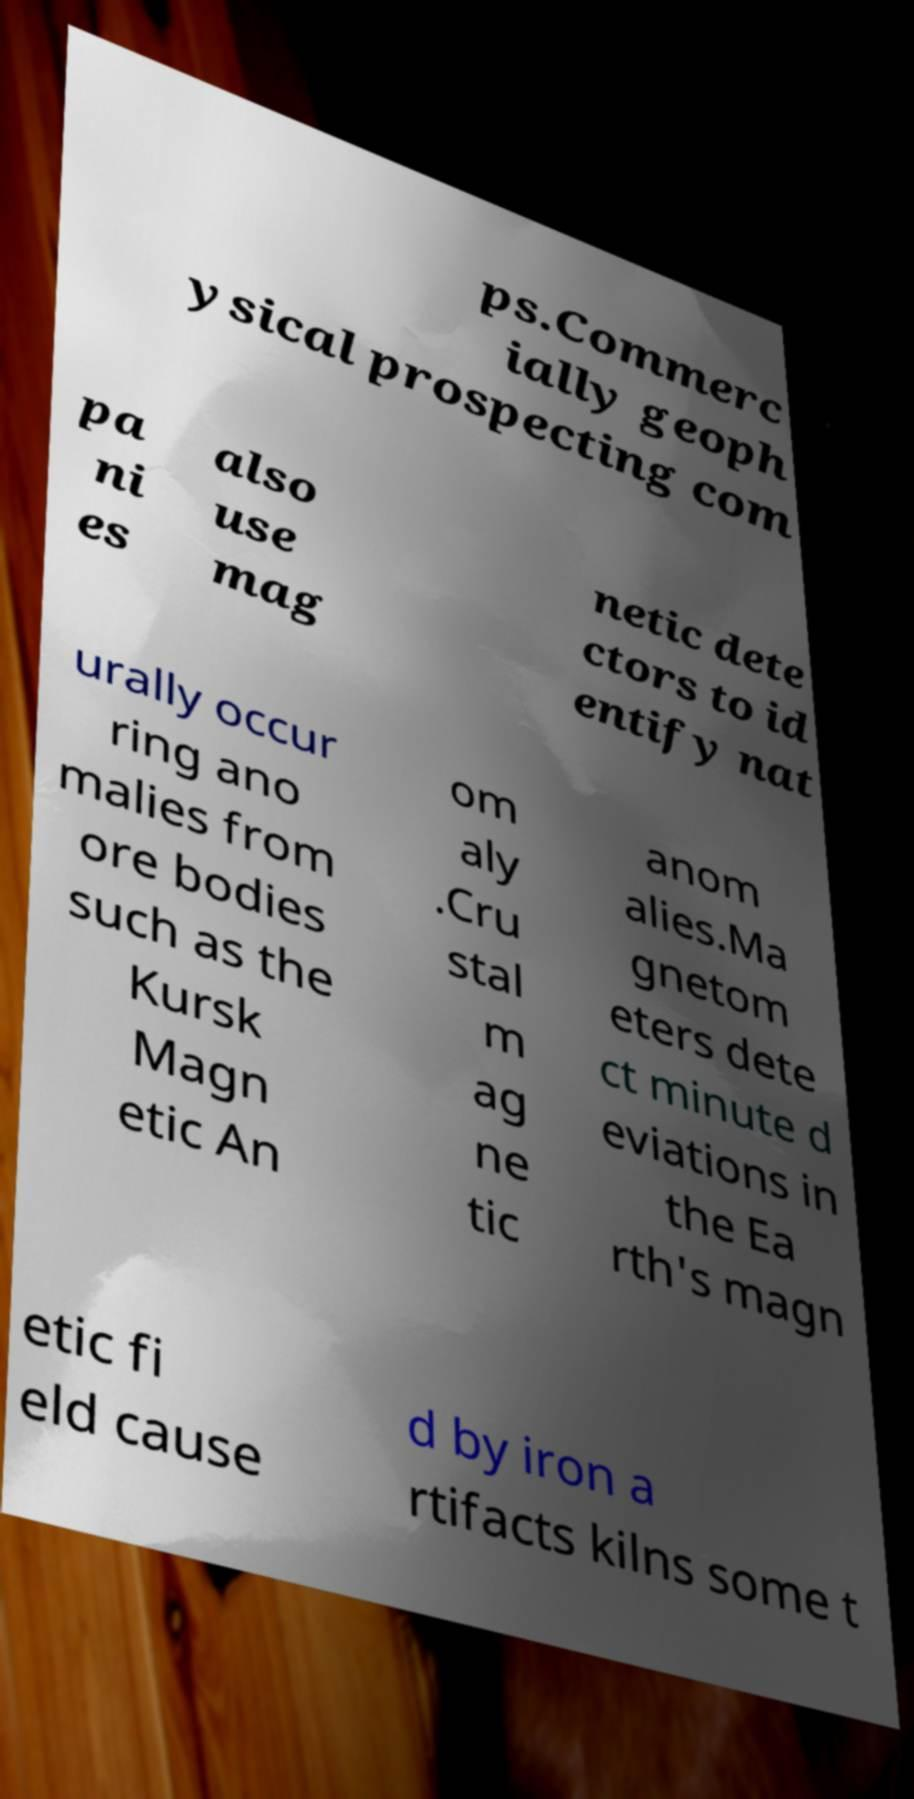I need the written content from this picture converted into text. Can you do that? ps.Commerc ially geoph ysical prospecting com pa ni es also use mag netic dete ctors to id entify nat urally occur ring ano malies from ore bodies such as the Kursk Magn etic An om aly .Cru stal m ag ne tic anom alies.Ma gnetom eters dete ct minute d eviations in the Ea rth's magn etic fi eld cause d by iron a rtifacts kilns some t 